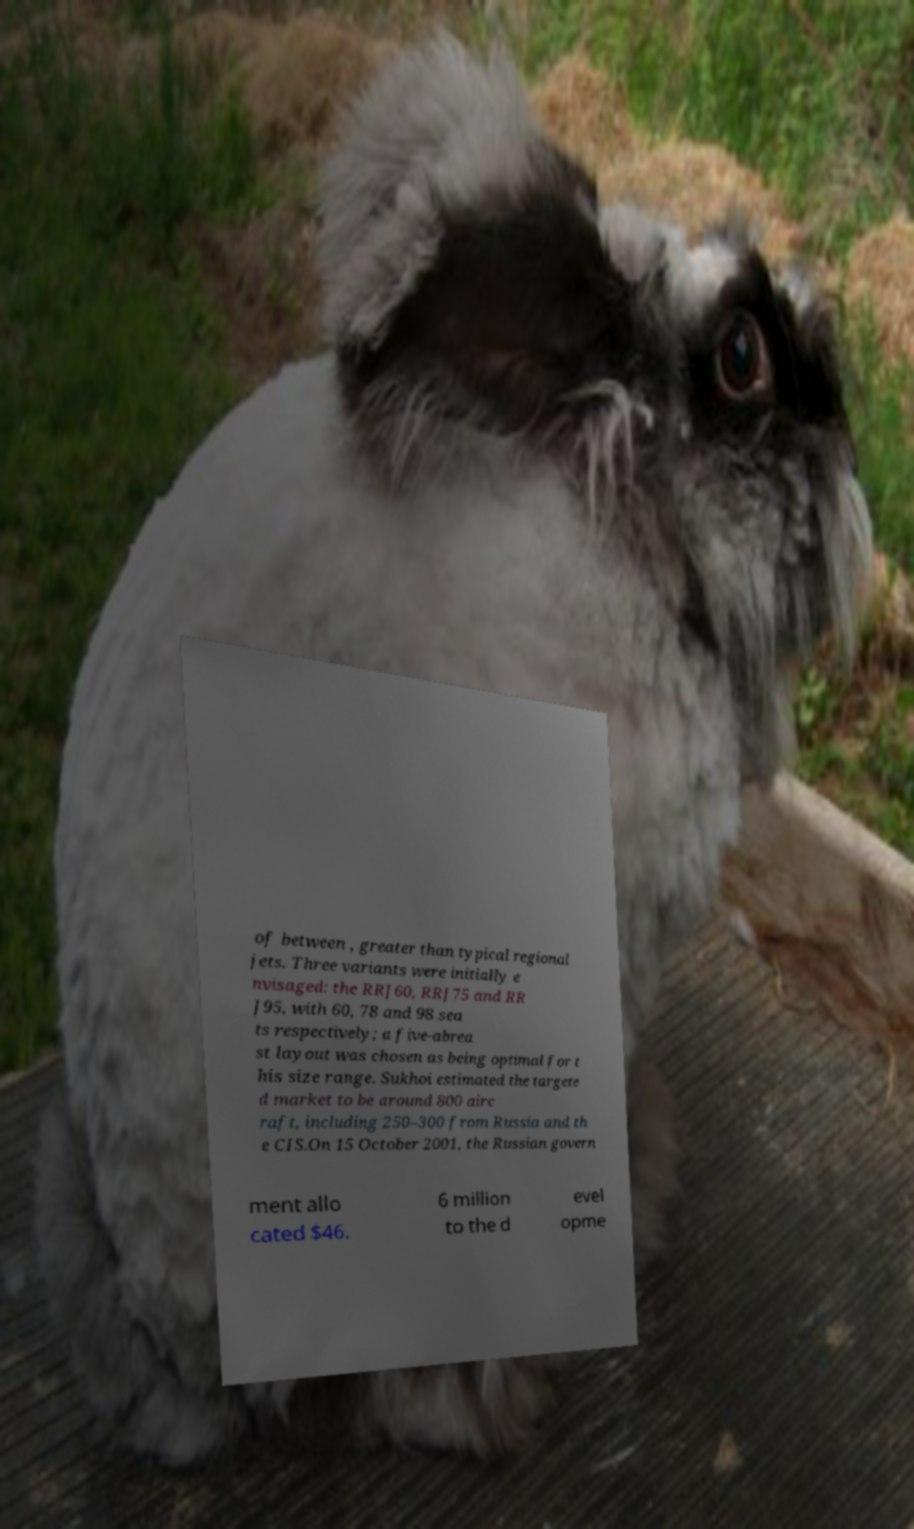There's text embedded in this image that I need extracted. Can you transcribe it verbatim? of between , greater than typical regional jets. Three variants were initially e nvisaged: the RRJ60, RRJ75 and RR J95, with 60, 78 and 98 sea ts respectively; a five-abrea st layout was chosen as being optimal for t his size range. Sukhoi estimated the targete d market to be around 800 airc raft, including 250–300 from Russia and th e CIS.On 15 October 2001, the Russian govern ment allo cated $46. 6 million to the d evel opme 